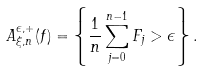<formula> <loc_0><loc_0><loc_500><loc_500>A _ { \xi , n } ^ { \epsilon , + } ( f ) = \left \{ \frac { 1 } { n } \sum _ { j = 0 } ^ { n - 1 } F _ { j } > \epsilon \right \} .</formula> 